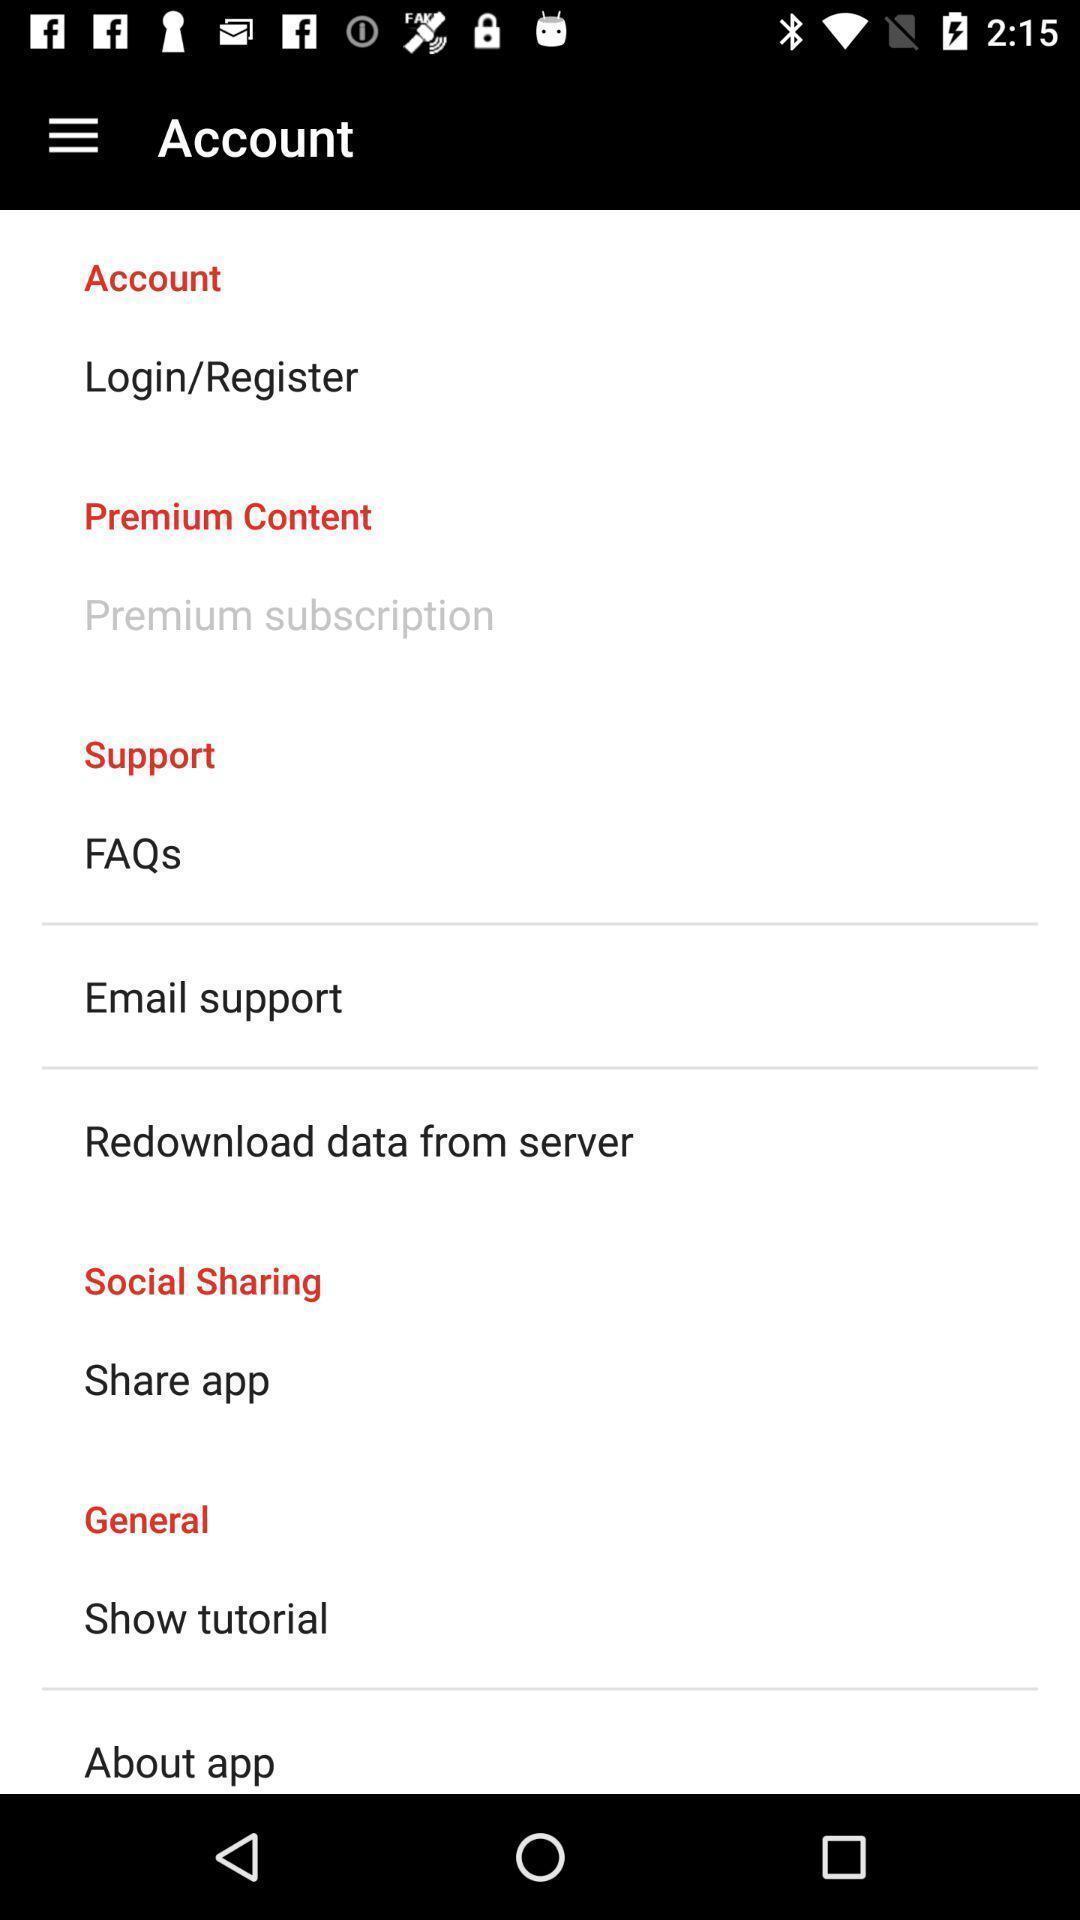Describe the key features of this screenshot. Page showing variety of account settings. 